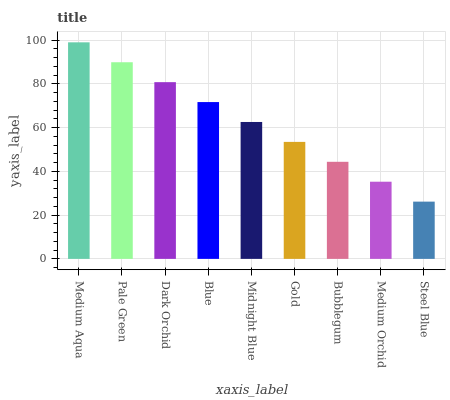Is Steel Blue the minimum?
Answer yes or no. Yes. Is Medium Aqua the maximum?
Answer yes or no. Yes. Is Pale Green the minimum?
Answer yes or no. No. Is Pale Green the maximum?
Answer yes or no. No. Is Medium Aqua greater than Pale Green?
Answer yes or no. Yes. Is Pale Green less than Medium Aqua?
Answer yes or no. Yes. Is Pale Green greater than Medium Aqua?
Answer yes or no. No. Is Medium Aqua less than Pale Green?
Answer yes or no. No. Is Midnight Blue the high median?
Answer yes or no. Yes. Is Midnight Blue the low median?
Answer yes or no. Yes. Is Dark Orchid the high median?
Answer yes or no. No. Is Steel Blue the low median?
Answer yes or no. No. 